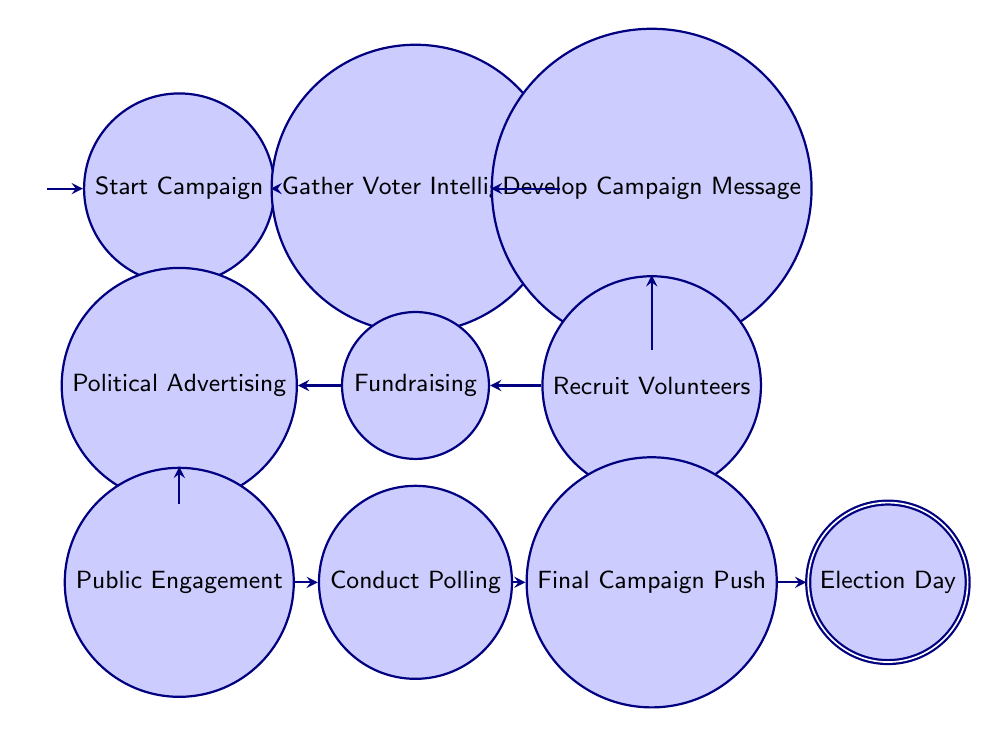What is the starting point of the campaign? The diagram indicates that the starting point of the campaign is labeled "Start Campaign." This is the initial state before any actions are taken.
Answer: Start Campaign How many nodes are in the diagram? To determine the number of nodes, we can count each distinct state shown in the diagram. There are 9 nodes in total: Start Campaign, Gather Voter Intelligence, Develop Campaign Message, Recruit Volunteers, Fundraising, Political Advertising, Public Engagement, Conduct Polling, Final Campaign Push, and Election Day.
Answer: 9 What is the last action before Election Day? According to the diagram, the final action before reaching Election Day is labeled "Final Campaign Push." This indicates the last step taken in the campaign process right before the election.
Answer: Final Campaign Push Which node follows "Recruit Volunteers"? The flow of the diagram shows that after "Recruit Volunteers," the next action taken is "Fundraising." This establishes a sequential relationship between these two nodes.
Answer: Fundraising What type of action is "Conduct Polling"? The diagram categorizes "Conduct Polling" as an action since it is labeled as such within the context of the campaign strategy. Each node performs a specific action to progress the campaign.
Answer: Action What are the two actions that precede "Public Engagement"? From the transitions in the diagram, the actions that occur before "Public Engagement" are "Political Advertising" and "Fundraising." Understanding this sequence is crucial for grasping the campaign strategy.
Answer: Political Advertising, Fundraising What is the relationship between "Advertising" and "Polling"? The diagram demonstrates a directed relationship where "Political Advertising" leads directly to "Public Engagement," followed by "Conduct Polling." This indicates a clear order of operations in the campaign strategy.
Answer: Directly connected What happens after "Gather Voter Intelligence"? The next step that follows "Gather Voter Intelligence" is "Develop Campaign Message," showing the sequential nature of the steps in the election campaign strategy.
Answer: Develop Campaign Message How does the campaign progress from "Fundraising"? According to the diagram, after "Fundraising," the campaign progresses to "Political Advertising." This transition signifies the action taken once the financial resources are secured.
Answer: Political Advertising 